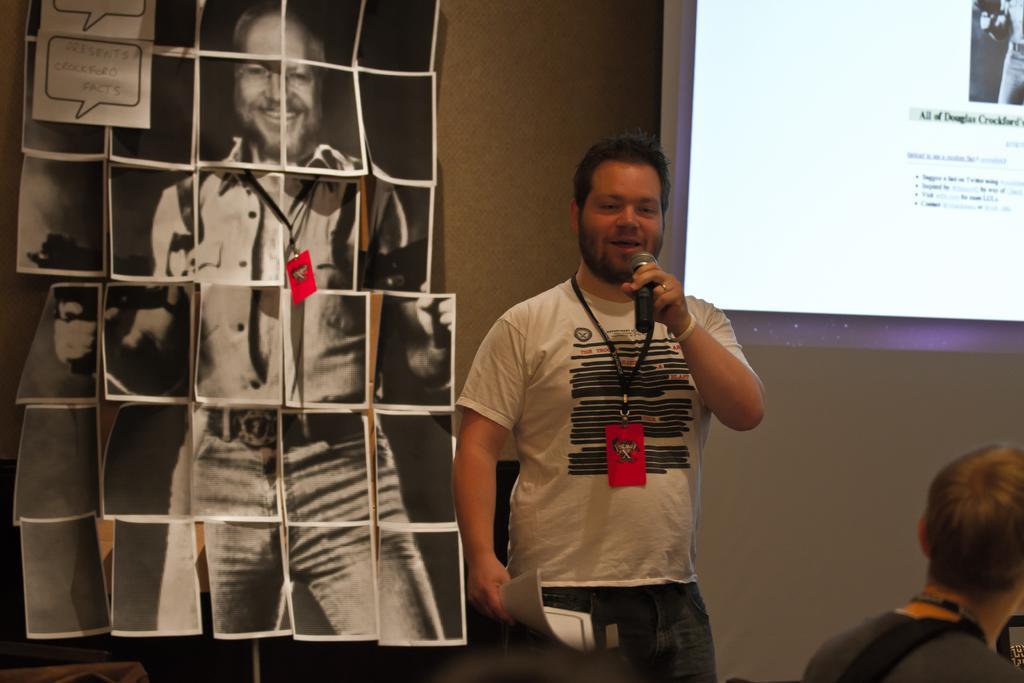How would you summarize this image in a sentence or two? In this image, we can see a man is holding a microphone and papers. He is talking and seeing. At the bottom, we can see a person is wearing a tag. Background we can see a wall, few photographs and screen. 